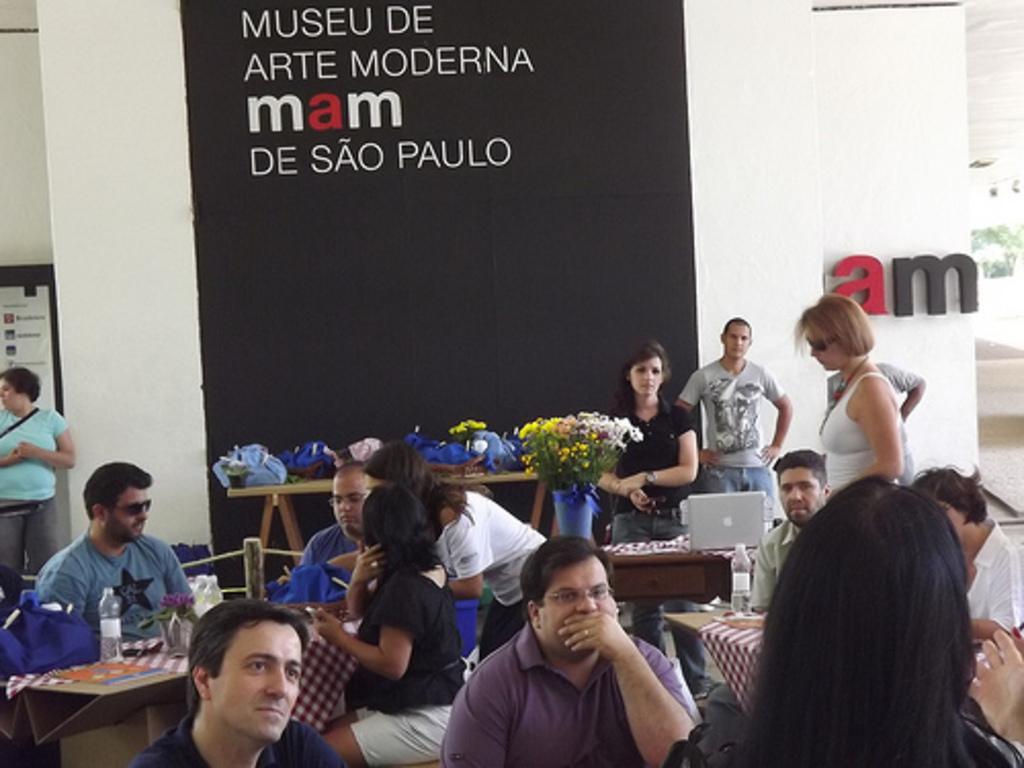Please provide a concise description of this image. In this image I can see a group of people are sitting on a chair in front of a table. On the table we have a glass bottle, a laptop and other objects on it. 